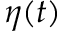Convert formula to latex. <formula><loc_0><loc_0><loc_500><loc_500>\eta ( t )</formula> 